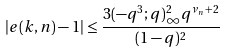Convert formula to latex. <formula><loc_0><loc_0><loc_500><loc_500>| e ( k , n ) - 1 | \leq \frac { 3 ( - q ^ { 3 } ; q ) _ { \infty } ^ { 2 } q ^ { \nu _ { n } + 2 } } { ( 1 - q ) ^ { 2 } }</formula> 